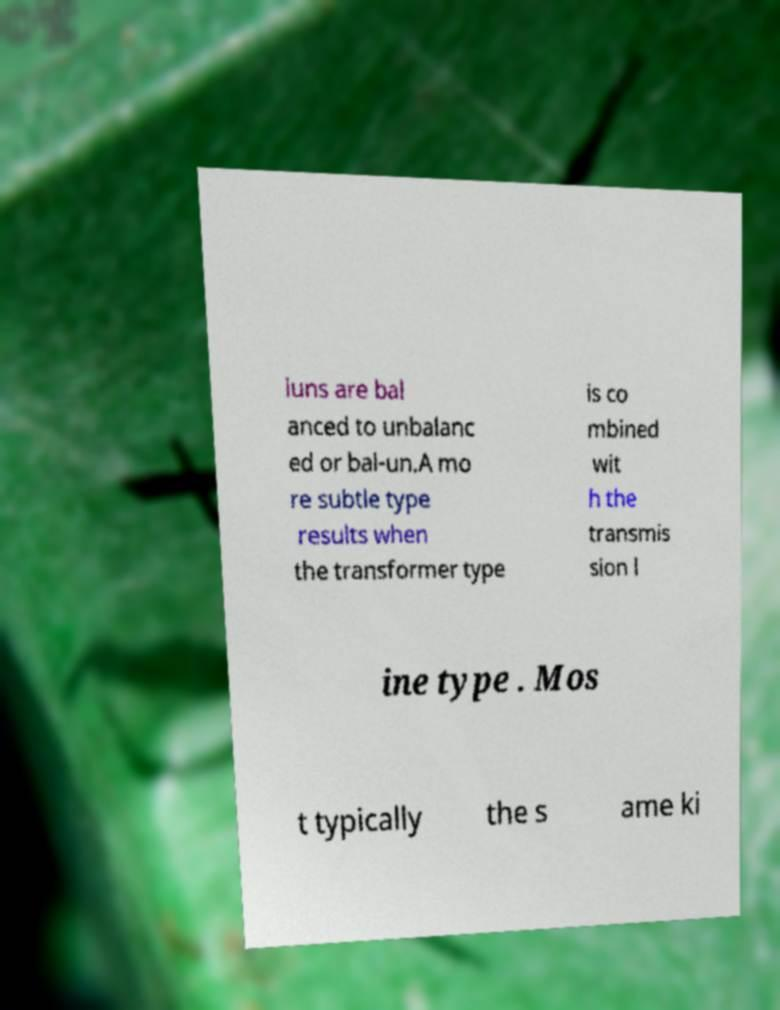Could you assist in decoding the text presented in this image and type it out clearly? luns are bal anced to unbalanc ed or bal-un.A mo re subtle type results when the transformer type is co mbined wit h the transmis sion l ine type . Mos t typically the s ame ki 